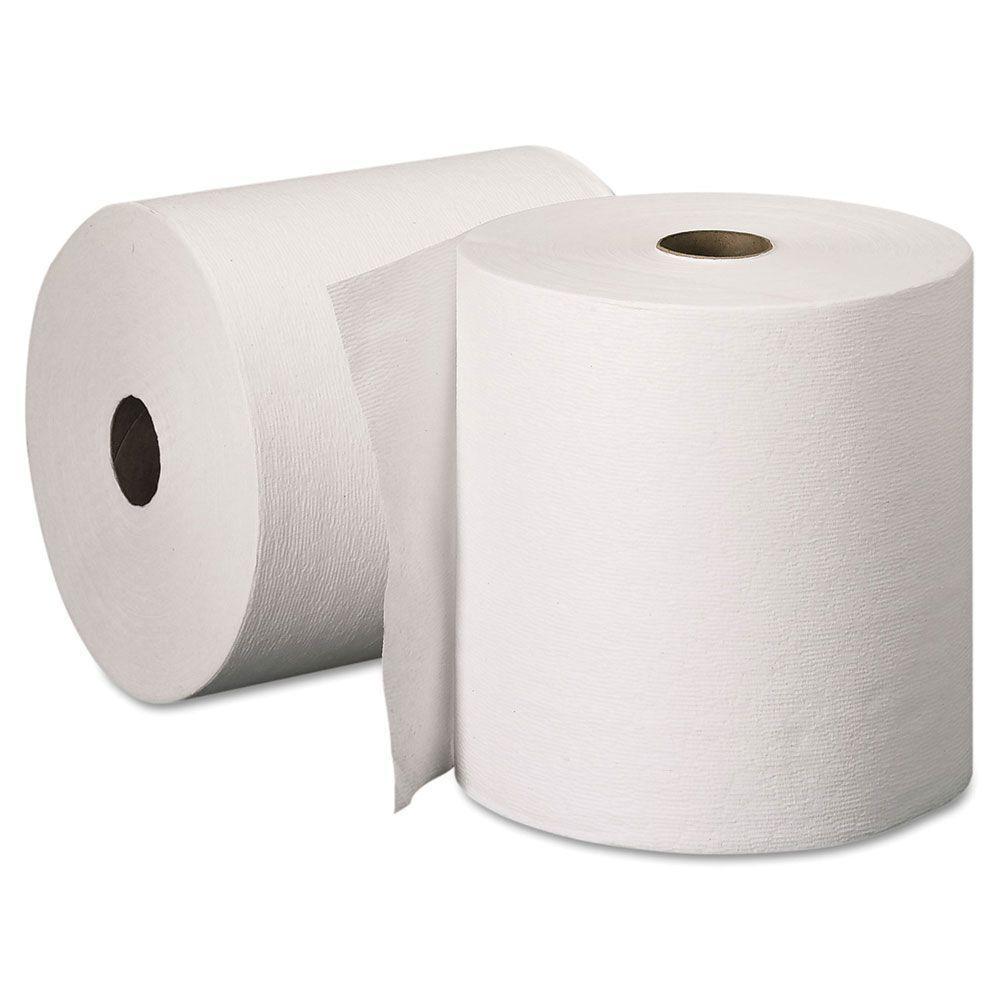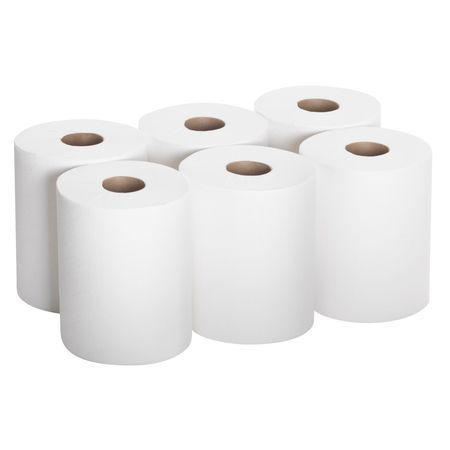The first image is the image on the left, the second image is the image on the right. For the images shown, is this caption "there are exactly two rolls of paper in the image on the left" true? Answer yes or no. Yes. The first image is the image on the left, the second image is the image on the right. Analyze the images presented: Is the assertion "Exactly two rolls of white paper towels are standing upright." valid? Answer yes or no. No. 